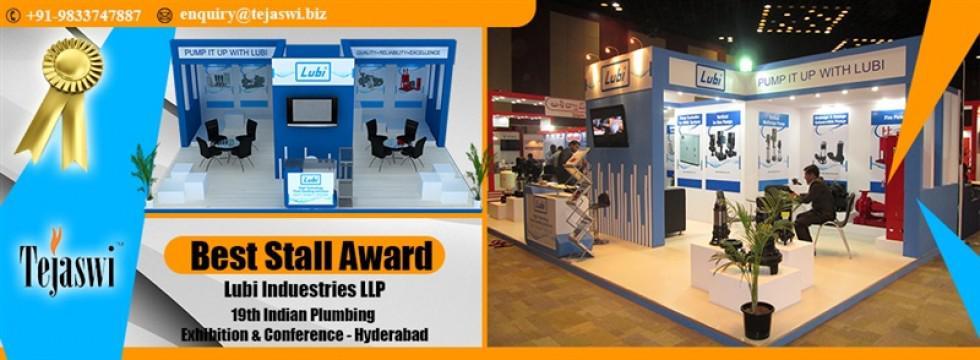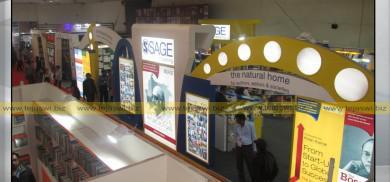The first image is the image on the left, the second image is the image on the right. For the images displayed, is the sentence "The left image includes a standing blue display with an S shape in a circle somewhere above it." factually correct? Answer yes or no. No. The first image is the image on the left, the second image is the image on the right. For the images shown, is this caption "In at least one image there is a person sitting on a chair looking at the desk in a kiosk." true? Answer yes or no. Yes. 